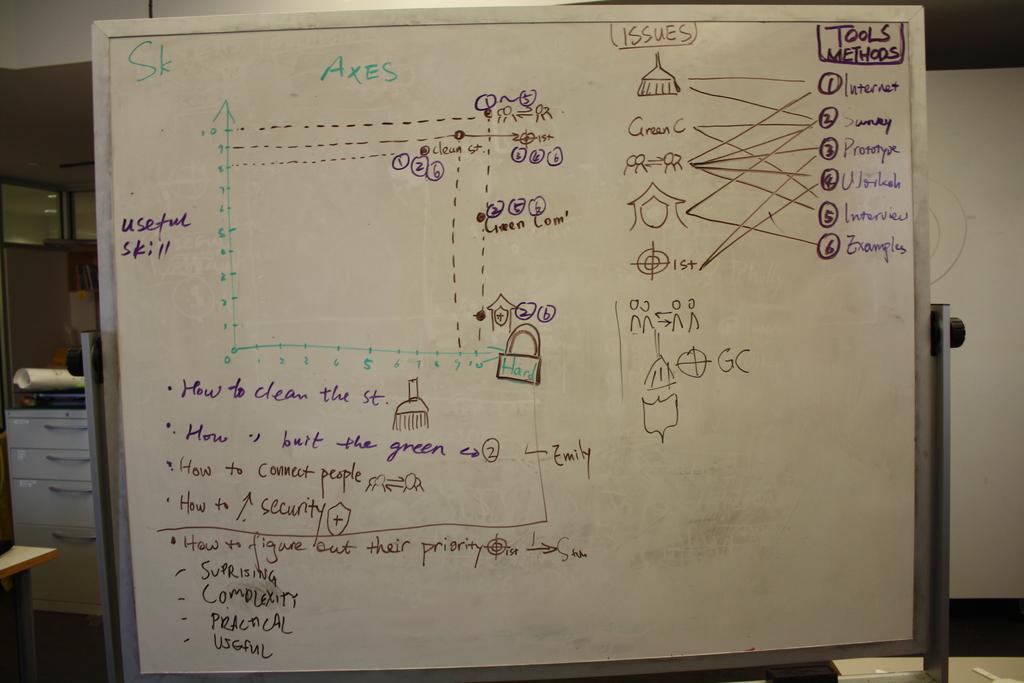Is how to connect people mentioned?
Provide a short and direct response. Yes. 